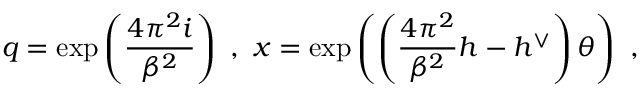Convert formula to latex. <formula><loc_0><loc_0><loc_500><loc_500>q = \exp \left ( \frac { 4 \pi ^ { 2 } i } { \beta ^ { 2 } } \right ) \ , \ x = \exp \left ( \left ( \frac { 4 \pi ^ { 2 } } { \beta ^ { 2 } } h - h ^ { \vee } \right ) \theta \right ) \ ,</formula> 